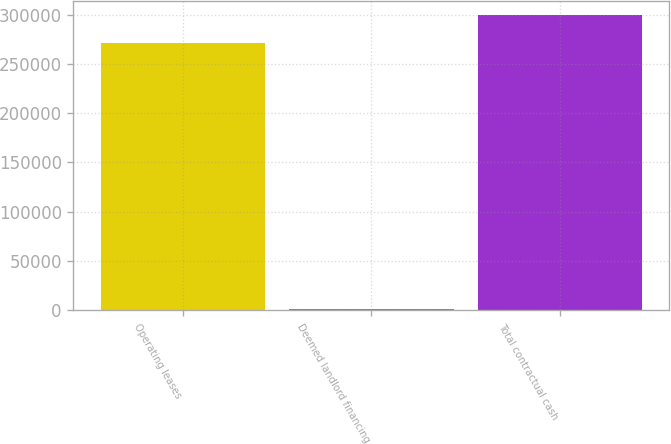Convert chart. <chart><loc_0><loc_0><loc_500><loc_500><bar_chart><fcel>Operating leases<fcel>Deemed landlord financing<fcel>Total contractual cash<nl><fcel>271911<fcel>788<fcel>299511<nl></chart> 